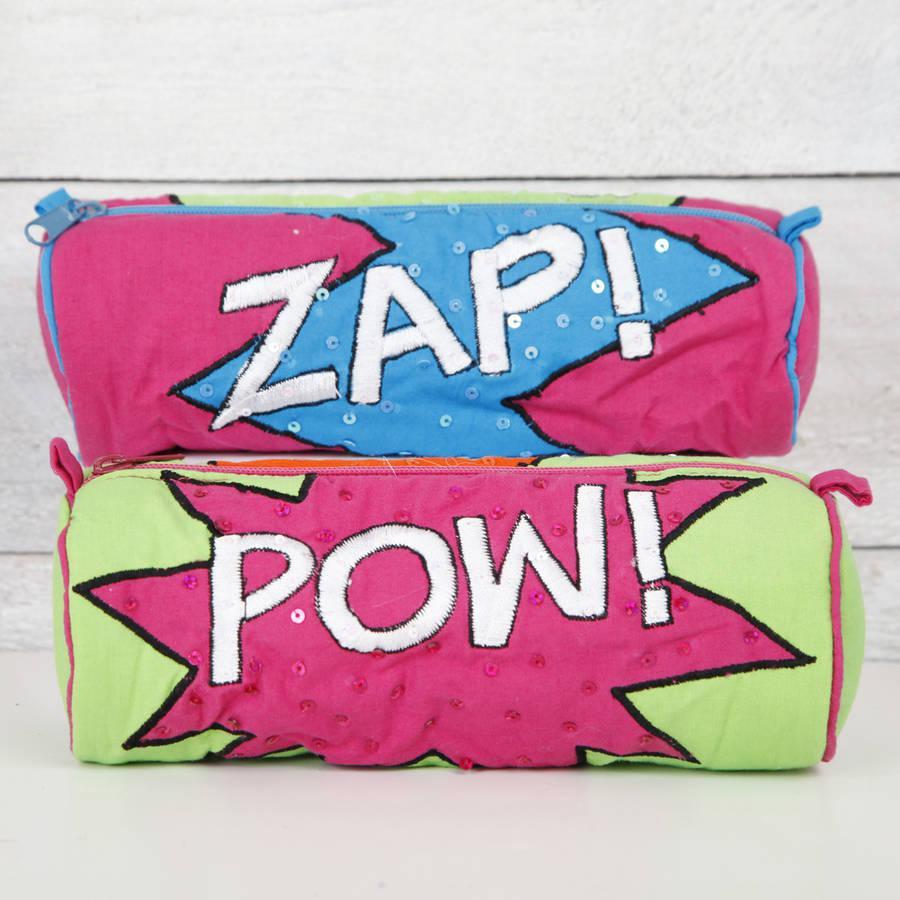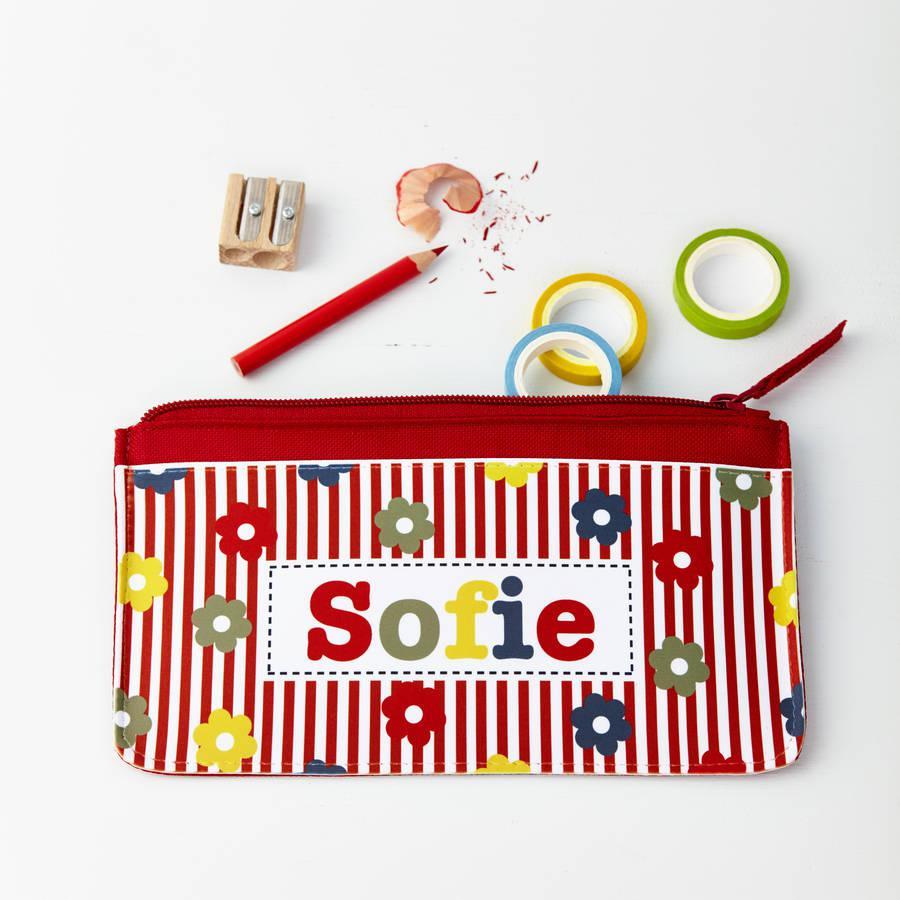The first image is the image on the left, the second image is the image on the right. Evaluate the accuracy of this statement regarding the images: "One image shows a pencil case lying on top of notepaper.". Is it true? Answer yes or no. No. The first image is the image on the left, the second image is the image on the right. Assess this claim about the two images: "There are strawberries pictured on a total of 1 pencil case.". Correct or not? Answer yes or no. No. 